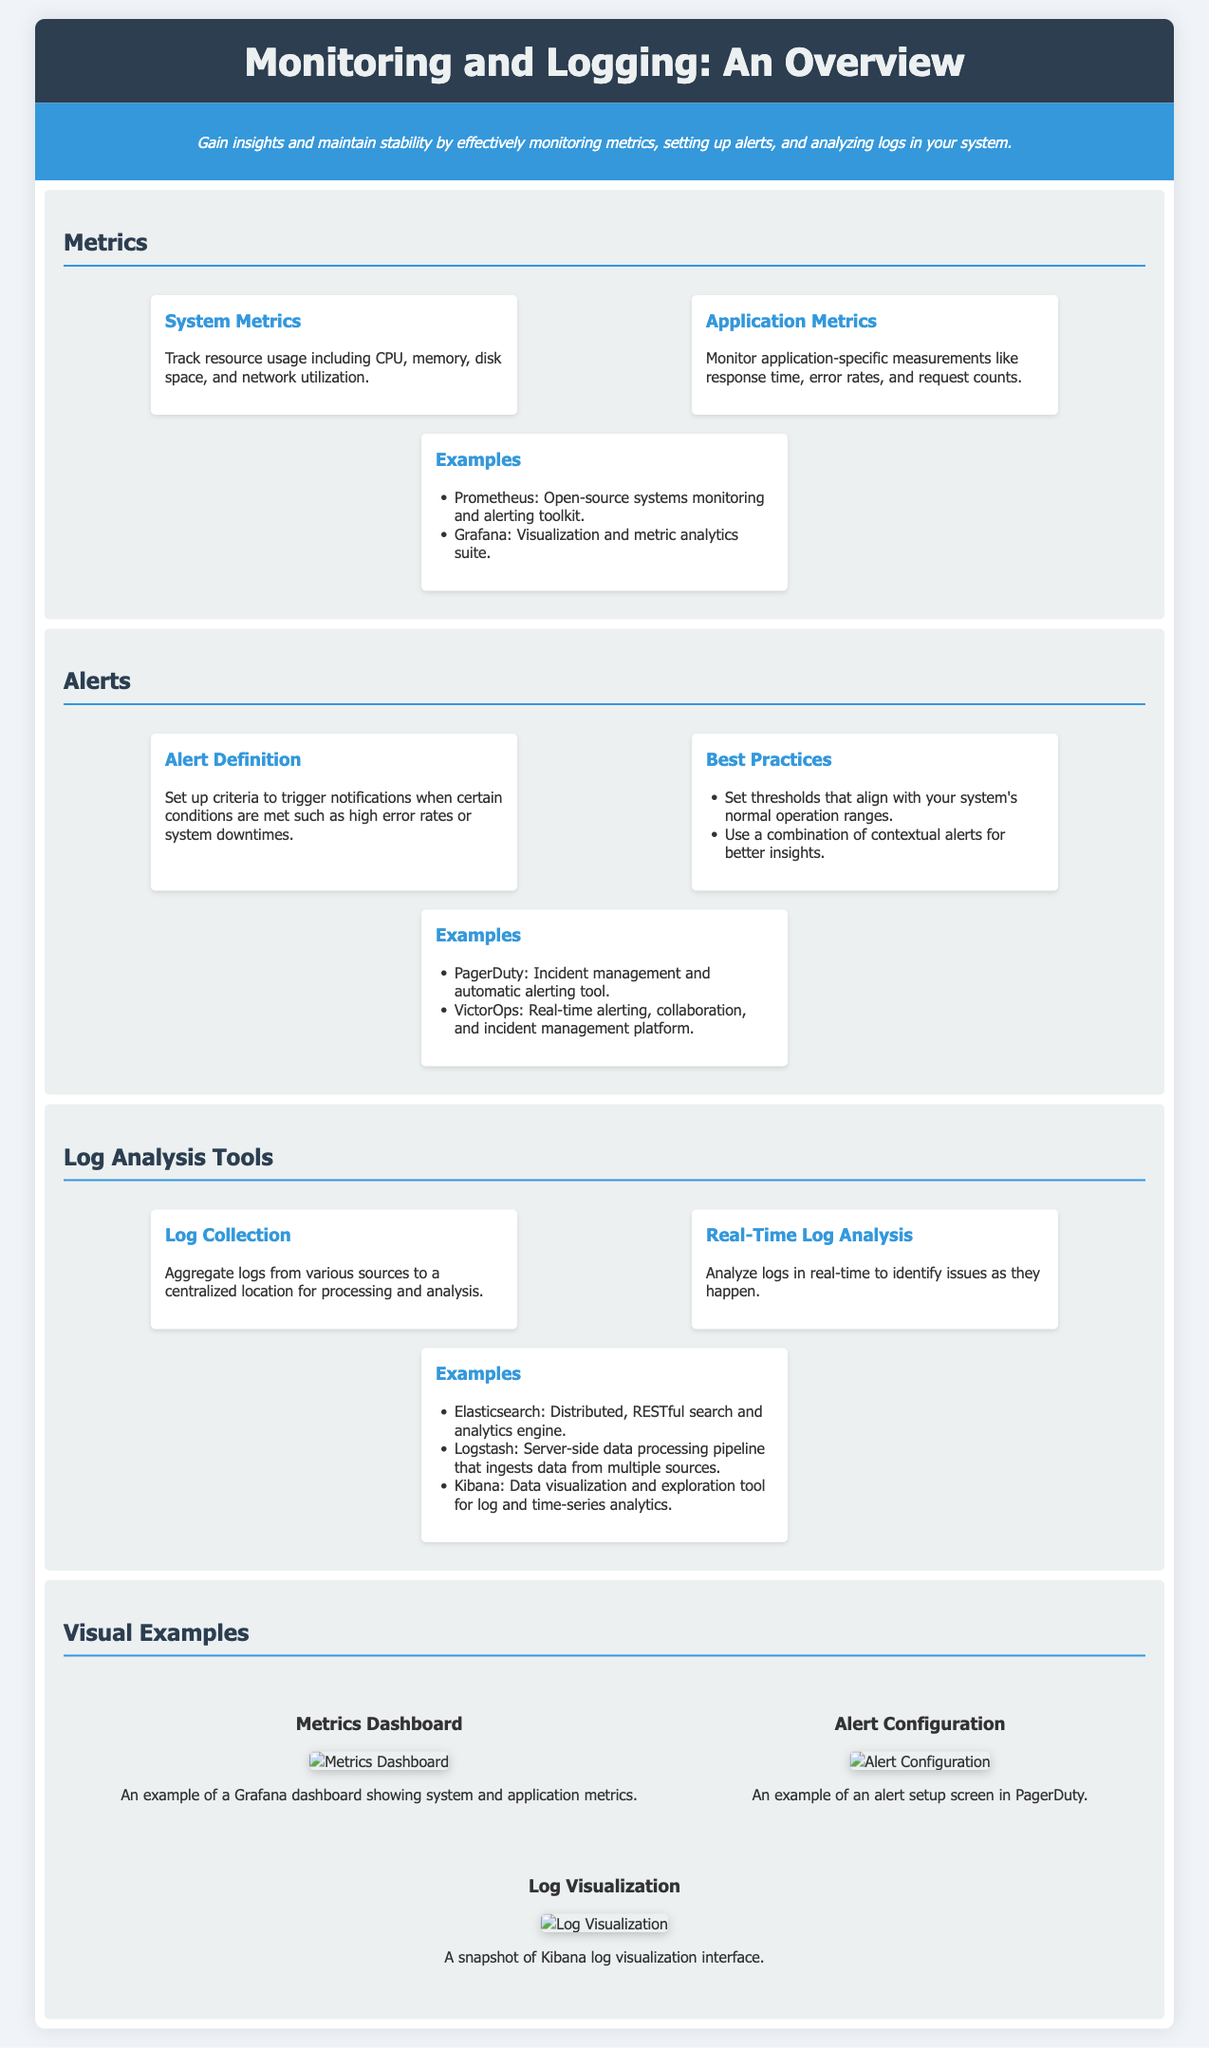What does the infographic overview focus on? The main focus of the infographic is on monitoring metrics, setting up alerts, and analyzing logs to gain insights and maintain stability in systems.
Answer: Monitoring and logging How many main sections are in this infographic? The infographic consists of four main sections: Metrics, Alerts, Log Analysis Tools, and Visual Examples.
Answer: Four What type of metrics are tracked under System Metrics? System Metrics track resource usage like CPU, memory, disk space, and network utilization.
Answer: Resource usage Which tool is mentioned for real-time log analysis? The tool mentioned for real-time log analysis in the document is Elasticsearch.
Answer: Elasticsearch What is the purpose of alerts? Alerts are used to trigger notifications when certain conditions, like high error rates or system downtimes, are met.
Answer: Trigger notifications What is an example of an alert configuration tool listed in the infographic? The example of an alert configuration tool included in the infographic is PagerDuty.
Answer: PagerDuty Which visualization tool is illustrated for log analysis? The infographic illustrates Kibana as a data visualization tool used for log analytics.
Answer: Kibana What color is used for the header in the infographic? The header background color in the infographic is dark blue.
Answer: Dark blue 